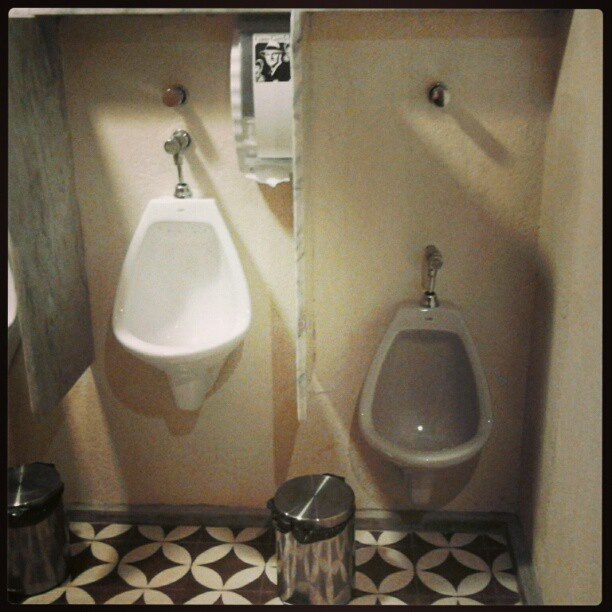Describe the objects in this image and their specific colors. I can see toilet in black, lightgray, and darkgray tones and toilet in black and gray tones in this image. 